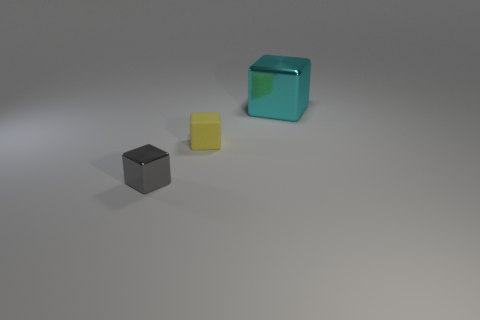Add 3 tiny shiny cubes. How many objects exist? 6 Subtract all cyan objects. Subtract all tiny purple spheres. How many objects are left? 2 Add 2 large metallic things. How many large metallic things are left? 3 Add 1 gray cubes. How many gray cubes exist? 2 Subtract 1 gray blocks. How many objects are left? 2 